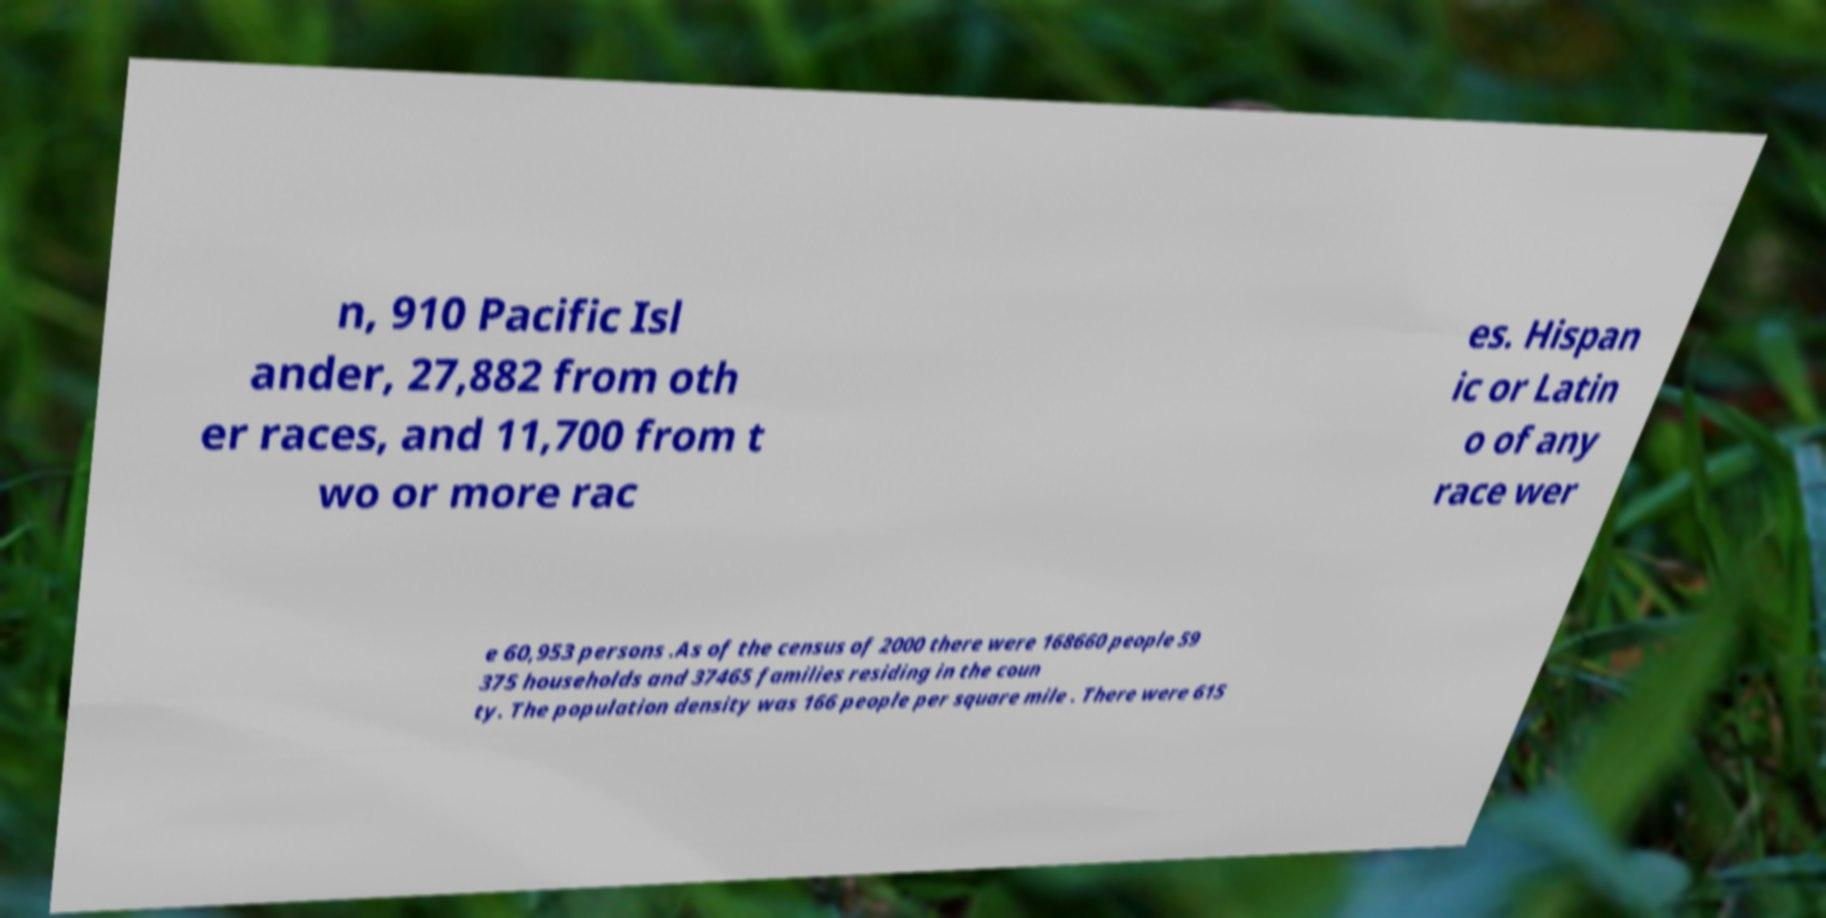What messages or text are displayed in this image? I need them in a readable, typed format. n, 910 Pacific Isl ander, 27,882 from oth er races, and 11,700 from t wo or more rac es. Hispan ic or Latin o of any race wer e 60,953 persons .As of the census of 2000 there were 168660 people 59 375 households and 37465 families residing in the coun ty. The population density was 166 people per square mile . There were 615 